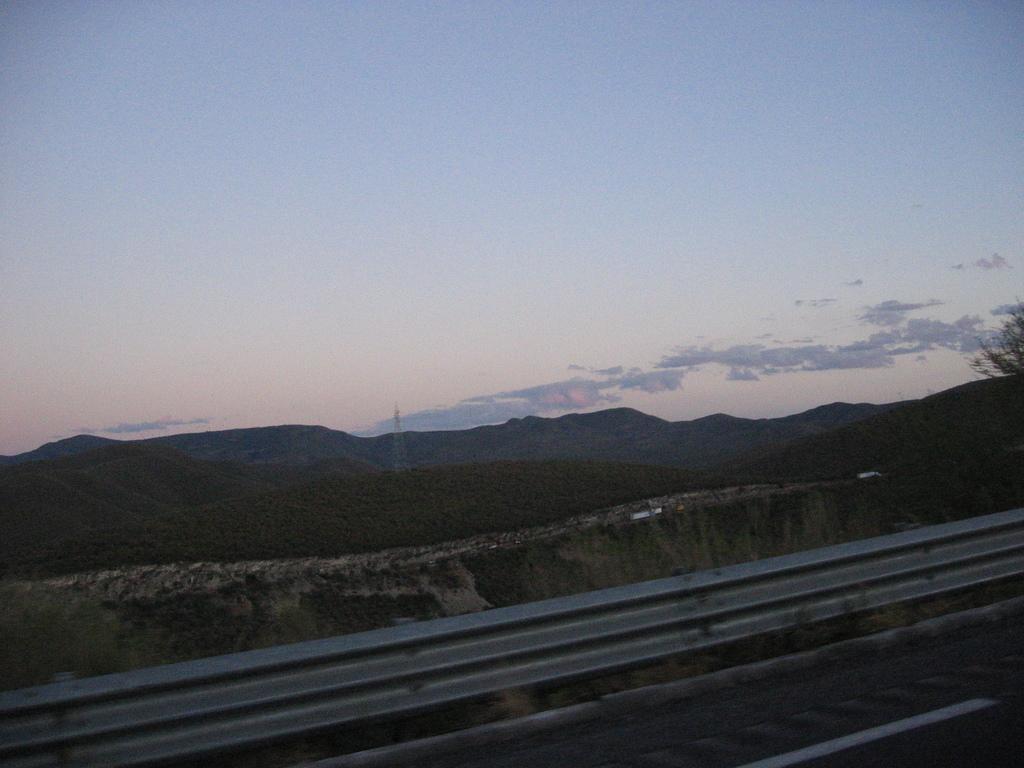Could you give a brief overview of what you see in this image? In this image there are hills and sky. At the bottom there is a road. On the right we can see a tree. 